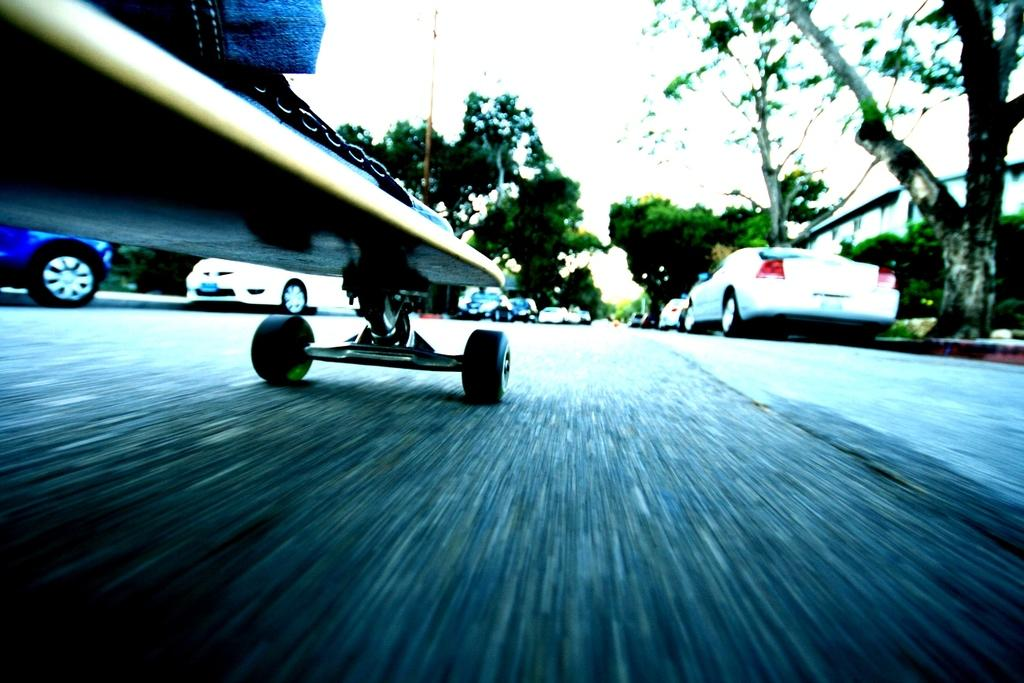What is the main object in the image? There is a skateboard in the image. What can be seen in the top right corner of the image? Trees are visible in the top right corner of the image. What type of vehicles are depicted in the middle of the image? There are images of cars in the middle of the image. What is visible at the top of the image? The sky is visible at the top of the image. What type of pest can be seen crawling on the skateboard in the image? There are no pests visible on the skateboard in the image. Is there a note attached to the skateboard in the image? There is no note present in the image. 